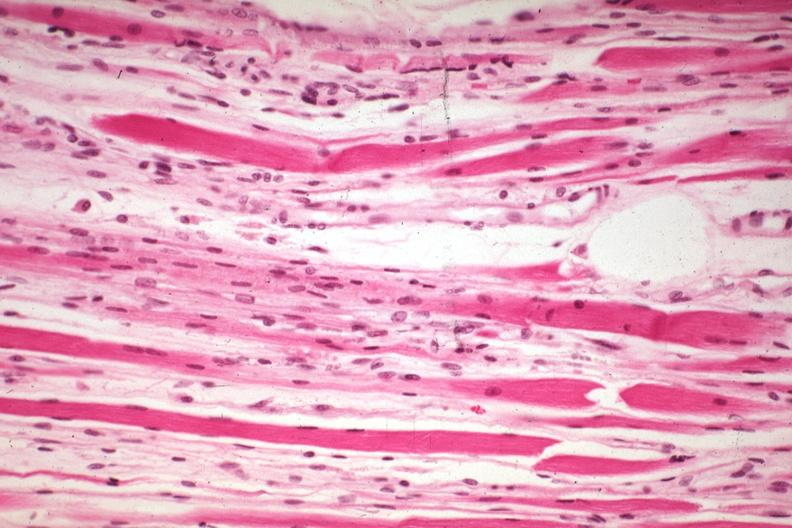what is high excellent steroid induced?
Answer the question using a single word or phrase. Atrophy 